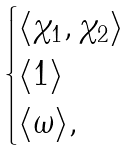Convert formula to latex. <formula><loc_0><loc_0><loc_500><loc_500>\begin{cases} \langle \chi _ { 1 } , \chi _ { 2 } \rangle \\ \langle 1 \rangle \\ \langle \omega \rangle , \end{cases}</formula> 